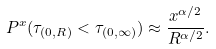Convert formula to latex. <formula><loc_0><loc_0><loc_500><loc_500>P ^ { x } ( \tau _ { ( 0 , R ) } < \tau _ { ( 0 , \infty ) } ) \approx \frac { x ^ { \alpha / 2 } } { R ^ { \alpha / 2 } } .</formula> 